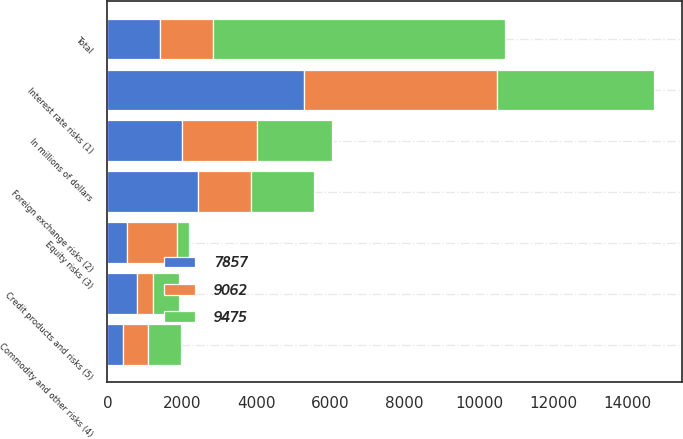Convert chart. <chart><loc_0><loc_0><loc_500><loc_500><stacked_bar_chart><ecel><fcel>In millions of dollars<fcel>Interest rate risks (1)<fcel>Foreign exchange risks (2)<fcel>Equity risks (3)<fcel>Commodity and other risks (4)<fcel>Credit products and risks (5)<fcel>Total<nl><fcel>9062<fcel>2018<fcel>5186<fcel>1423<fcel>1346<fcel>662<fcel>445<fcel>1423<nl><fcel>7857<fcel>2017<fcel>5301<fcel>2435<fcel>525<fcel>425<fcel>789<fcel>1423<nl><fcel>9475<fcel>2016<fcel>4229<fcel>1699<fcel>330<fcel>899<fcel>700<fcel>7857<nl></chart> 